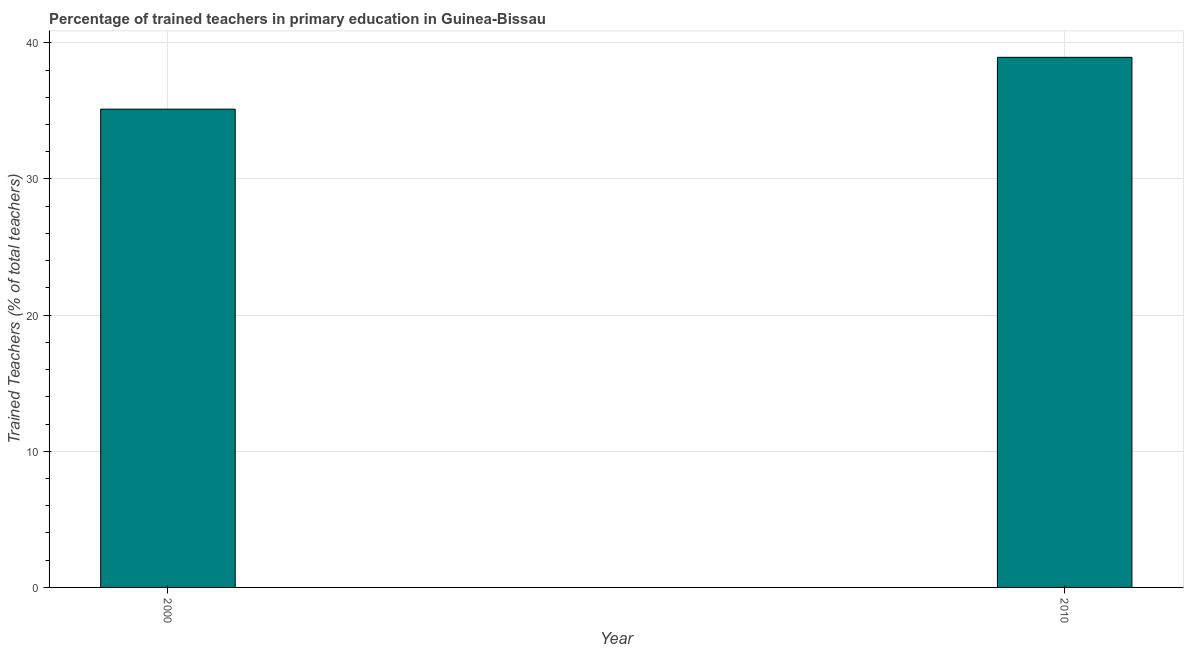Does the graph contain any zero values?
Provide a short and direct response. No. What is the title of the graph?
Give a very brief answer. Percentage of trained teachers in primary education in Guinea-Bissau. What is the label or title of the X-axis?
Your response must be concise. Year. What is the label or title of the Y-axis?
Keep it short and to the point. Trained Teachers (% of total teachers). What is the percentage of trained teachers in 2010?
Your answer should be compact. 38.93. Across all years, what is the maximum percentage of trained teachers?
Keep it short and to the point. 38.93. Across all years, what is the minimum percentage of trained teachers?
Provide a succinct answer. 35.12. In which year was the percentage of trained teachers maximum?
Keep it short and to the point. 2010. In which year was the percentage of trained teachers minimum?
Give a very brief answer. 2000. What is the sum of the percentage of trained teachers?
Provide a succinct answer. 74.06. What is the difference between the percentage of trained teachers in 2000 and 2010?
Give a very brief answer. -3.81. What is the average percentage of trained teachers per year?
Offer a terse response. 37.03. What is the median percentage of trained teachers?
Offer a very short reply. 37.03. What is the ratio of the percentage of trained teachers in 2000 to that in 2010?
Provide a short and direct response. 0.9. In how many years, is the percentage of trained teachers greater than the average percentage of trained teachers taken over all years?
Offer a terse response. 1. How many bars are there?
Your answer should be very brief. 2. How many years are there in the graph?
Provide a short and direct response. 2. What is the difference between two consecutive major ticks on the Y-axis?
Make the answer very short. 10. What is the Trained Teachers (% of total teachers) in 2000?
Your answer should be very brief. 35.12. What is the Trained Teachers (% of total teachers) in 2010?
Your response must be concise. 38.93. What is the difference between the Trained Teachers (% of total teachers) in 2000 and 2010?
Provide a succinct answer. -3.81. What is the ratio of the Trained Teachers (% of total teachers) in 2000 to that in 2010?
Keep it short and to the point. 0.9. 